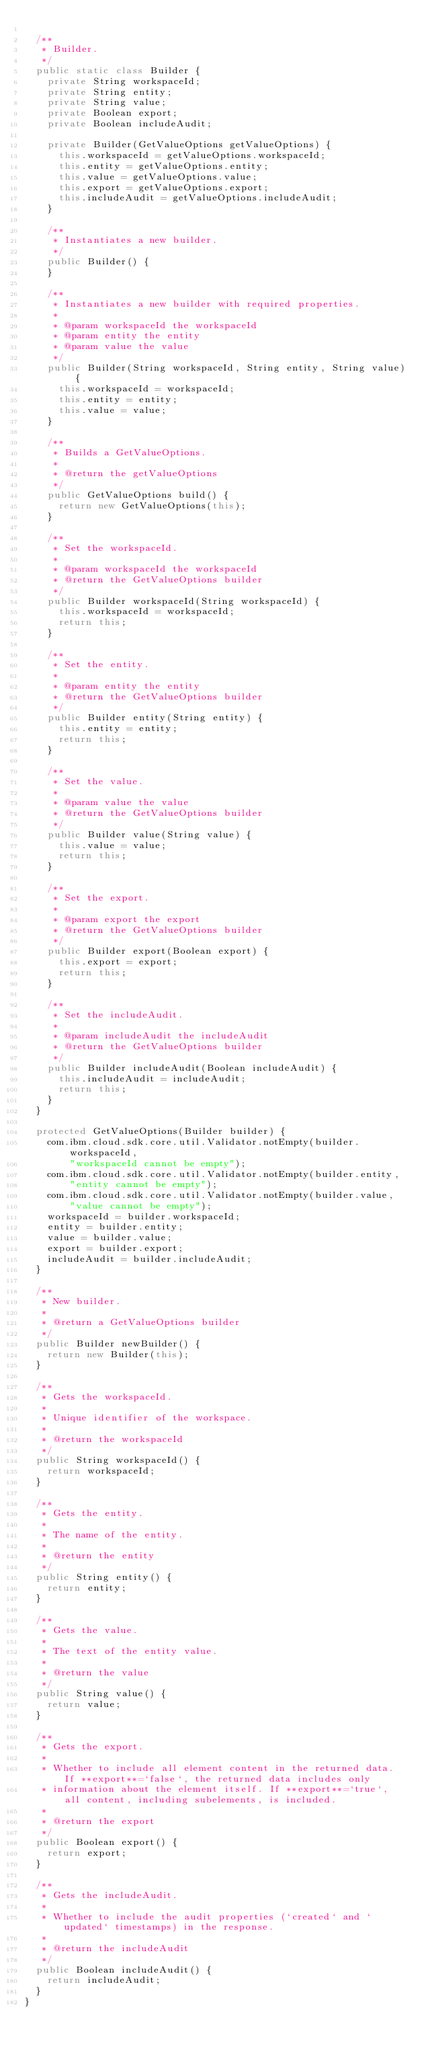<code> <loc_0><loc_0><loc_500><loc_500><_Java_>
  /**
   * Builder.
   */
  public static class Builder {
    private String workspaceId;
    private String entity;
    private String value;
    private Boolean export;
    private Boolean includeAudit;

    private Builder(GetValueOptions getValueOptions) {
      this.workspaceId = getValueOptions.workspaceId;
      this.entity = getValueOptions.entity;
      this.value = getValueOptions.value;
      this.export = getValueOptions.export;
      this.includeAudit = getValueOptions.includeAudit;
    }

    /**
     * Instantiates a new builder.
     */
    public Builder() {
    }

    /**
     * Instantiates a new builder with required properties.
     *
     * @param workspaceId the workspaceId
     * @param entity the entity
     * @param value the value
     */
    public Builder(String workspaceId, String entity, String value) {
      this.workspaceId = workspaceId;
      this.entity = entity;
      this.value = value;
    }

    /**
     * Builds a GetValueOptions.
     *
     * @return the getValueOptions
     */
    public GetValueOptions build() {
      return new GetValueOptions(this);
    }

    /**
     * Set the workspaceId.
     *
     * @param workspaceId the workspaceId
     * @return the GetValueOptions builder
     */
    public Builder workspaceId(String workspaceId) {
      this.workspaceId = workspaceId;
      return this;
    }

    /**
     * Set the entity.
     *
     * @param entity the entity
     * @return the GetValueOptions builder
     */
    public Builder entity(String entity) {
      this.entity = entity;
      return this;
    }

    /**
     * Set the value.
     *
     * @param value the value
     * @return the GetValueOptions builder
     */
    public Builder value(String value) {
      this.value = value;
      return this;
    }

    /**
     * Set the export.
     *
     * @param export the export
     * @return the GetValueOptions builder
     */
    public Builder export(Boolean export) {
      this.export = export;
      return this;
    }

    /**
     * Set the includeAudit.
     *
     * @param includeAudit the includeAudit
     * @return the GetValueOptions builder
     */
    public Builder includeAudit(Boolean includeAudit) {
      this.includeAudit = includeAudit;
      return this;
    }
  }

  protected GetValueOptions(Builder builder) {
    com.ibm.cloud.sdk.core.util.Validator.notEmpty(builder.workspaceId,
        "workspaceId cannot be empty");
    com.ibm.cloud.sdk.core.util.Validator.notEmpty(builder.entity,
        "entity cannot be empty");
    com.ibm.cloud.sdk.core.util.Validator.notEmpty(builder.value,
        "value cannot be empty");
    workspaceId = builder.workspaceId;
    entity = builder.entity;
    value = builder.value;
    export = builder.export;
    includeAudit = builder.includeAudit;
  }

  /**
   * New builder.
   *
   * @return a GetValueOptions builder
   */
  public Builder newBuilder() {
    return new Builder(this);
  }

  /**
   * Gets the workspaceId.
   *
   * Unique identifier of the workspace.
   *
   * @return the workspaceId
   */
  public String workspaceId() {
    return workspaceId;
  }

  /**
   * Gets the entity.
   *
   * The name of the entity.
   *
   * @return the entity
   */
  public String entity() {
    return entity;
  }

  /**
   * Gets the value.
   *
   * The text of the entity value.
   *
   * @return the value
   */
  public String value() {
    return value;
  }

  /**
   * Gets the export.
   *
   * Whether to include all element content in the returned data. If **export**=`false`, the returned data includes only
   * information about the element itself. If **export**=`true`, all content, including subelements, is included.
   *
   * @return the export
   */
  public Boolean export() {
    return export;
  }

  /**
   * Gets the includeAudit.
   *
   * Whether to include the audit properties (`created` and `updated` timestamps) in the response.
   *
   * @return the includeAudit
   */
  public Boolean includeAudit() {
    return includeAudit;
  }
}
</code> 